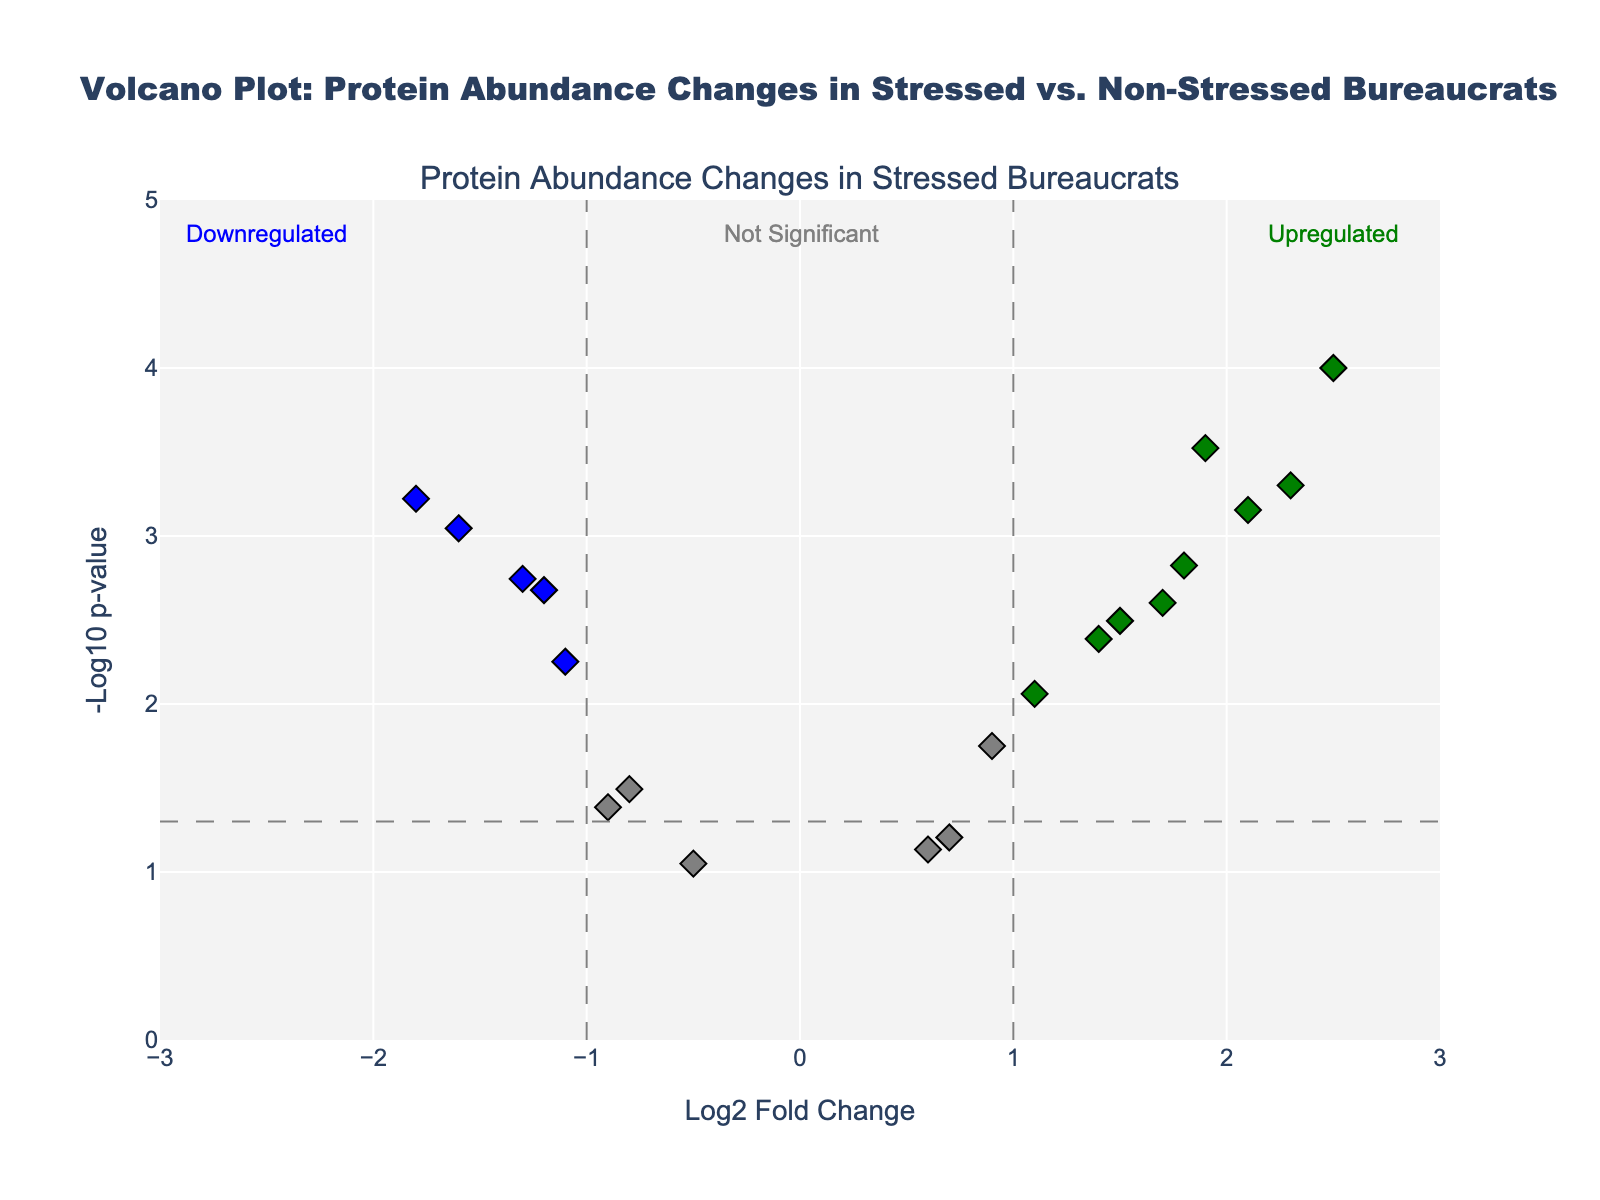What's the title of the figure? The title appears at the top of the figure. It is usually enclosed in a distinct font and large size for prominence. In this figure, it reads "Volcano Plot: Protein Abundance Changes in Stressed vs. Non-Stressed Bureaucrats".
Answer: Volcano Plot: Protein Abundance Changes in Stressed vs. Non-Stressed Bureaucrats What do the colors of the points represent? The colors represent different significances of protein changes. Gray indicates non-significant changes, red and green indicate significant upregulations, and blue indicates significant downregulations.
Answer: Different significance levels Where would you find the significantly upregulated proteins? Significantly upregulated proteins are marked in green and located in the upper-right quadrant, specifically to the right of the vertical threshold line (log2 fold change > 1) and above the horizontal threshold line (-log10 p-value > 1.301).
Answer: Upper-right quadrant Which protein shows the greatest increase in abundance? Look for the green point farthest to the right. This point represents C-reactive protein with the highest log2 fold change of 2.5.
Answer: C-reactive protein How many proteins are significantly upregulated? Count the number of green points to the right of the vertical threshold and above the horizontal threshold line. Six proteins meet these criteria: Heat shock protein 70, Superoxide dismutase, Glucocorticoid receptor, Interleukin-6, Tumor necrosis factor-alpha, and C-reactive protein.
Answer: 6 Which quadrant contains proteins with the most considerable decrease in abundance? The lower-left quadrant shows significantly downregulated proteins, specifically to the left of the vertical threshold line (log2 fold change < -1) and above the horizontal threshold line (-log10 p-value > 1.301).
Answer: Lower-left quadrant What does the x-axis represent? The x-axis represents the log2 fold change in protein abundance, indicating the magnitude and direction (up or down) of change between stressed and non-stressed bureaucrats.
Answer: Log2 fold change What does the y-axis represent? The y-axis represents the -log10 p-value, indicating the statistical significance of the observed changes; higher values signify greater significance.
Answer: -Log10 p-value Which protein is the most significantly downregulated? Look for the blue point farthest to the left. This point represents Melatonin, which shows the highest negative log2 fold change of -1.8.
Answer: Melatonin Which are the proteins just barely meeting the significance threshold? Examine points close to the threshold lines; Leptin (log2 fold change -1.1, p-value 0.0056) barely meets the significance criteria.
Answer: Leptin 